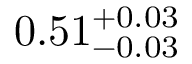<formula> <loc_0><loc_0><loc_500><loc_500>0 . 5 1 _ { - 0 . 0 3 } ^ { + 0 . 0 3 }</formula> 